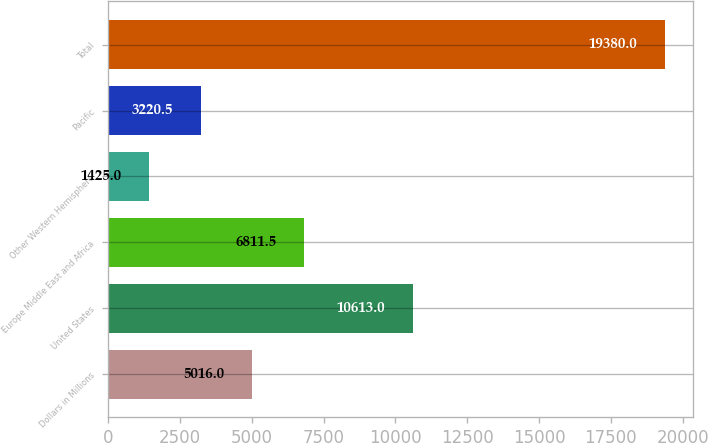Convert chart. <chart><loc_0><loc_0><loc_500><loc_500><bar_chart><fcel>Dollars in Millions<fcel>United States<fcel>Europe Middle East and Africa<fcel>Other Western Hemisphere<fcel>Pacific<fcel>Total<nl><fcel>5016<fcel>10613<fcel>6811.5<fcel>1425<fcel>3220.5<fcel>19380<nl></chart> 